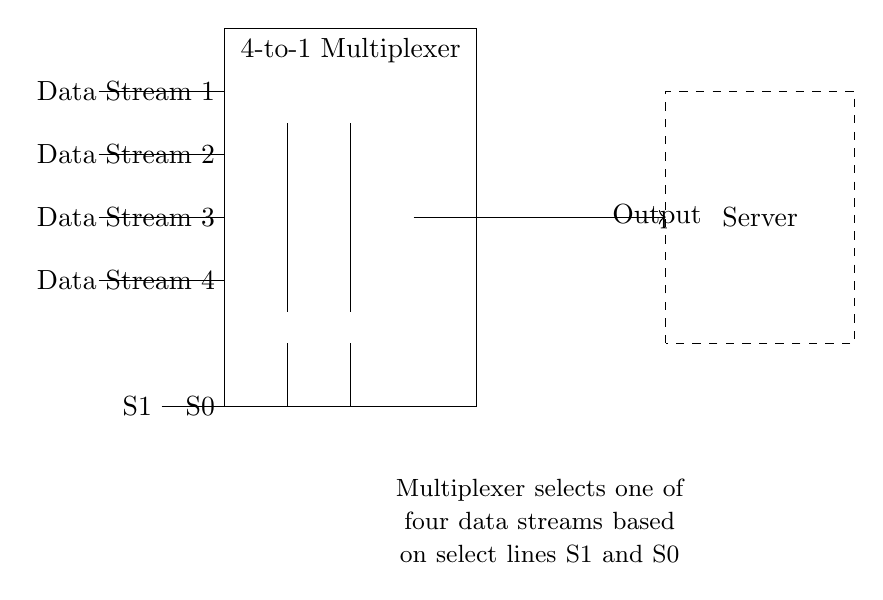What does the rectangle represent? The rectangle signifies the 4-to-1 multiplexer, which is the main component of this circuit. It is labeled clearly at the top of the rectangle.
Answer: 4-to-1 multiplexer How many data streams can this multiplexer handle? The multiplexer is specifically designed to select one of four data streams, as indicated by the four input lines labeled Data Stream 1, 2, 3, and 4.
Answer: Four data streams What are the select lines labeled as? The circuit diagram has two select lines, which are clearly labeled as S1 and S0 next to their respective connection points on the multiplexer.
Answer: S1 and S0 What type of circuit is represented by this diagram? The multiplexer is a type of digital circuit that routes data streams based on select signals, a fundamental characteristic of this circuit type.
Answer: Digital circuit Which component outputs the selected data stream? The output line from the multiplexer leads to the server, indicating that the server will receive the selected data stream. The output is labeled as "Output" on the line.
Answer: Output What is the function of the dashed rectangle? The dashed rectangle signifies the server, which is the destination for the output signal from the multiplexer. It is labeled and positioned nearby the output line.
Answer: Server What will happen if both select lines S1 and S0 are low? When both select lines are low, the multiplexer will output Data Stream 1 as it is configured to select the first data stream in this condition.
Answer: Data Stream 1 